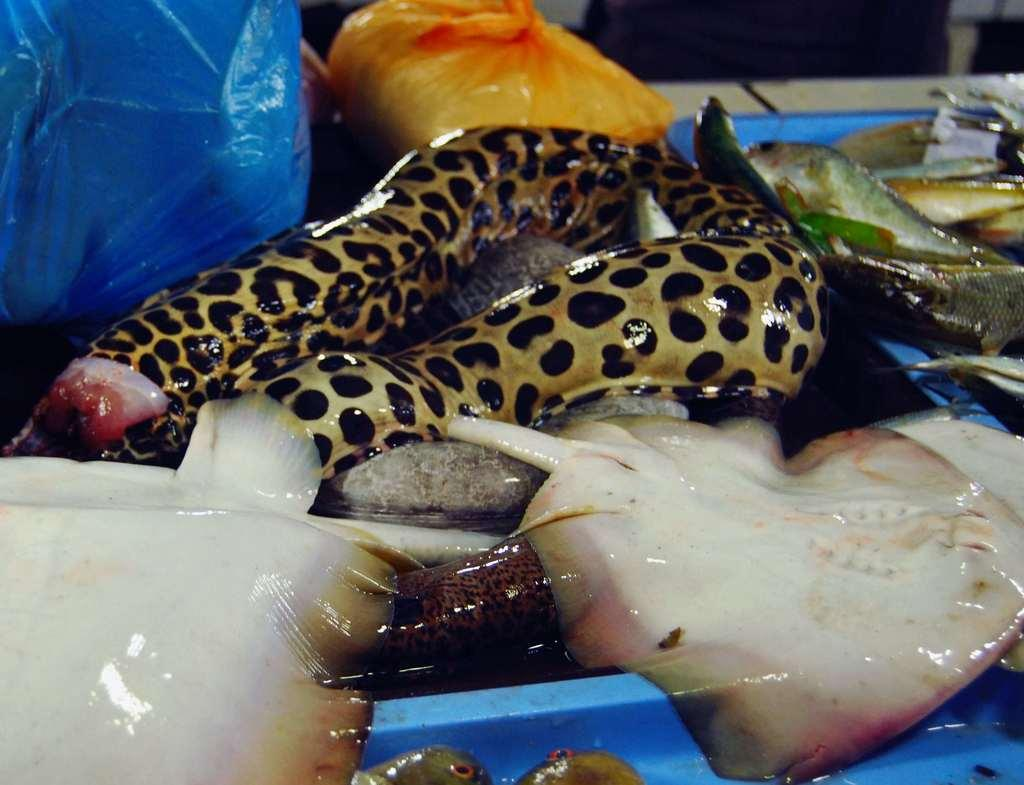What type of food items can be seen in the image? There are seafood items in the image. Can you describe the seafood items in more detail? Unfortunately, the facts provided do not offer more specific details about the seafood items. Are there any other elements in the image besides the seafood items? The facts provided do not mention any other elements in the image. What type of support can be seen in the image? There is no support present in the image; it only features seafood items. What game is being played in the image? There is no game being played in the image; it only features seafood items. 